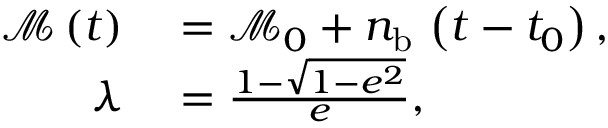<formula> <loc_0><loc_0><loc_500><loc_500>\begin{array} { r l } { \mathcal { M } \left ( t \right ) } & = \mathcal { M } _ { 0 } + n _ { b } \, \left ( t - t _ { 0 } \right ) , } \\ { \lambda } & = \frac { 1 - \sqrt { 1 - e ^ { 2 } } } { e } , } \end{array}</formula> 